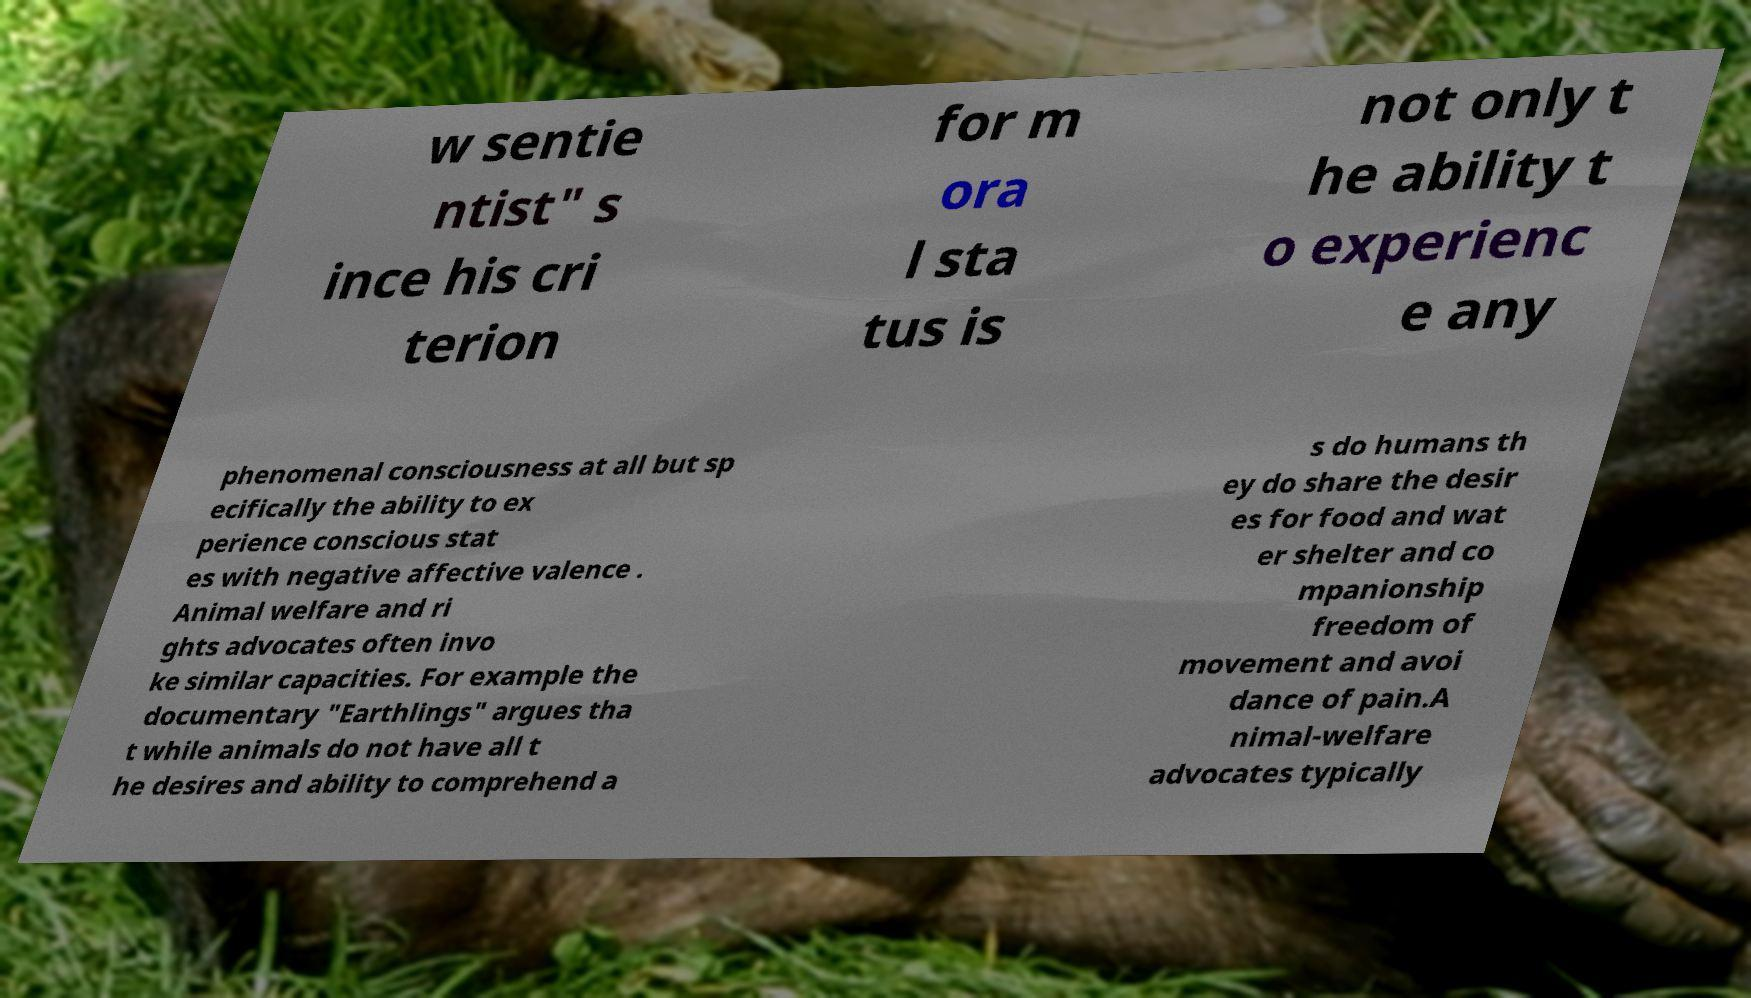Can you read and provide the text displayed in the image?This photo seems to have some interesting text. Can you extract and type it out for me? w sentie ntist" s ince his cri terion for m ora l sta tus is not only t he ability t o experienc e any phenomenal consciousness at all but sp ecifically the ability to ex perience conscious stat es with negative affective valence . Animal welfare and ri ghts advocates often invo ke similar capacities. For example the documentary "Earthlings" argues tha t while animals do not have all t he desires and ability to comprehend a s do humans th ey do share the desir es for food and wat er shelter and co mpanionship freedom of movement and avoi dance of pain.A nimal-welfare advocates typically 